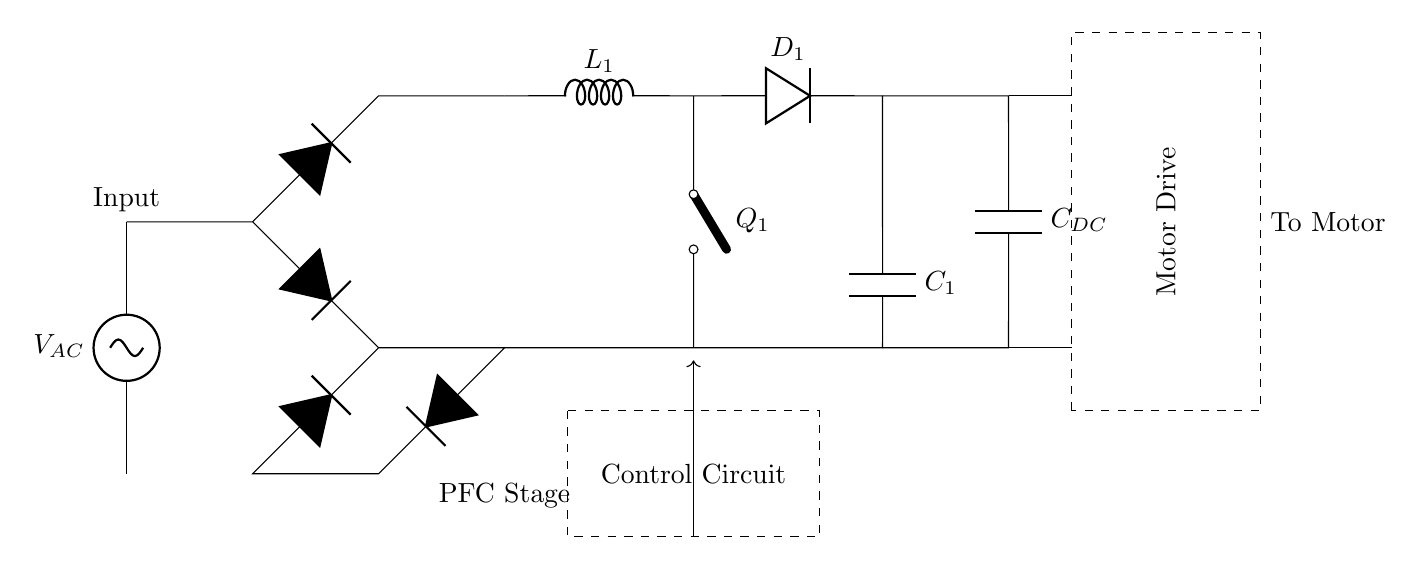What is the type of source used in the circuit? The circuit uses an AC source as indicated by the label on the component in the diagram. AC sources typically provide alternating current voltage for industrial applications.
Answer: AC source What component regulates the voltage to the motor drive? The Boost Converter, which includes the inductor, diode, and capacitor, helps to regulate and increase the DC voltage levels supplied to the motor drive.
Answer: Boost Converter How many diodes are present in the rectifier bridge? There are four diodes in the rectifier bridge configuration, arranged to convert AC voltage to DC voltage.
Answer: Four What is the role of the control circuit in this design? The control circuit regulates the operation of the power factor correction circuit, specifically managing the switching of the MOSFET and ensuring optimal performance of the motor drive system.
Answer: Regulation Identify the component labeled as "Q1" in the circuit. The component labeled "Q1" is a MOSFET, which acts as a switch in the boost converter section of the circuit, controlling the flow of energy to the output.
Answer: MOSFET What is the purpose of the inductor labeled "L1"? The inductor, labeled "L1," stores energy when current flows through it and helps in regulating the output voltage by smoothing the current transition in the boost converter section.
Answer: Energy storage What is the function of the capacitor labeled "C1"? The capacitor labeled "C1" serves to smooth and filter the output voltage from the boost converter, reducing voltage ripples, and stabilizing the voltage supplied to the motor drive.
Answer: Smoothing 